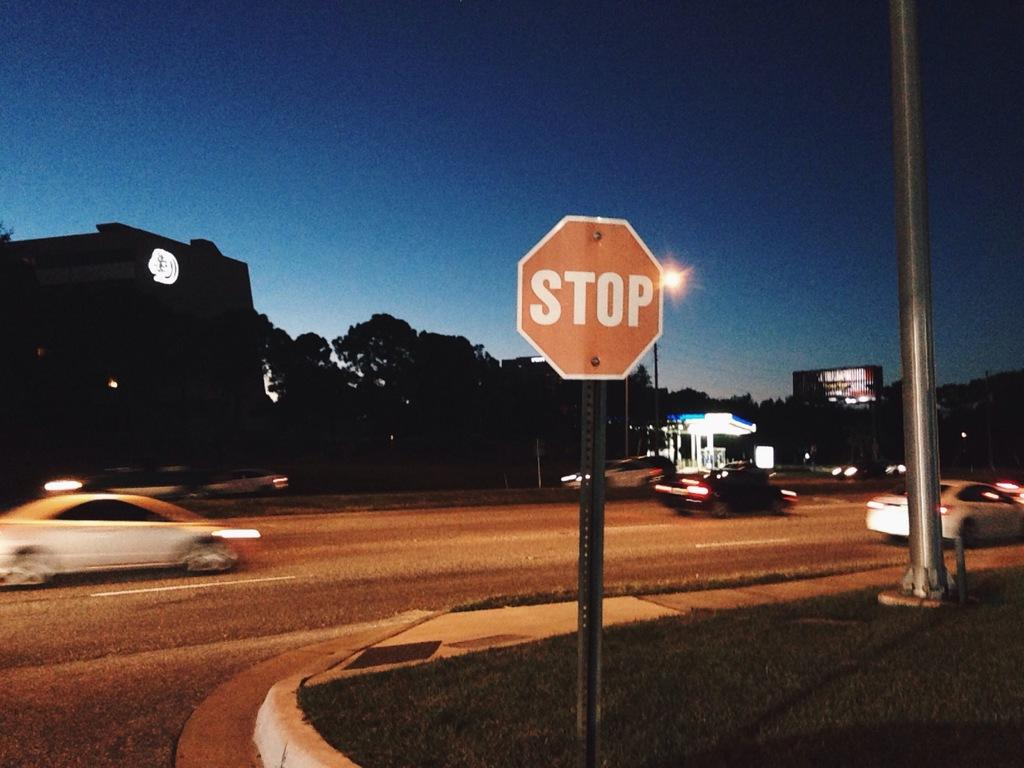What types of objects can be seen in the image? There are vehicles, poles, lights, buildings, posters, a sign board, and a shed in the image. What is the primary surface visible in the image? There is a road and ground with grass visible in the image. What else can be seen in the sky? The sky is visible in the image. How many babies are present in the image? There are no babies present in the image. What type of cattle can be seen grazing on the grass in the image? There is no cattle present in the image; it features vehicles, poles, lights, buildings, posters, a sign board, and a shed. 